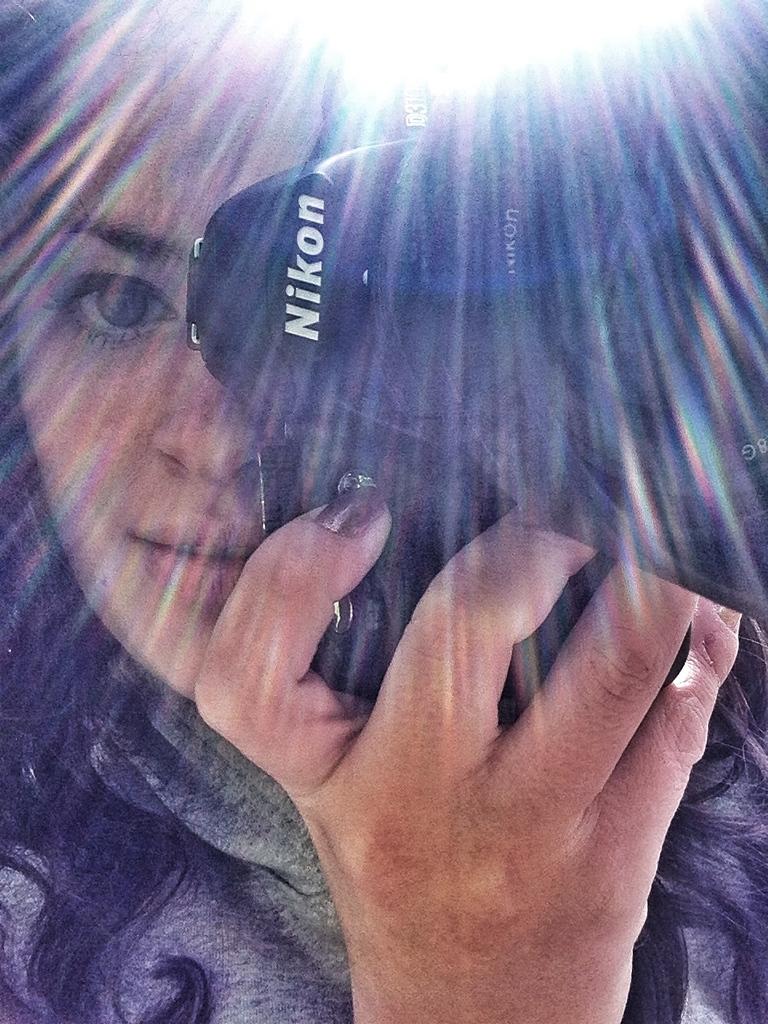What is the last letter found on the lens ring?
Your response must be concise. N. 